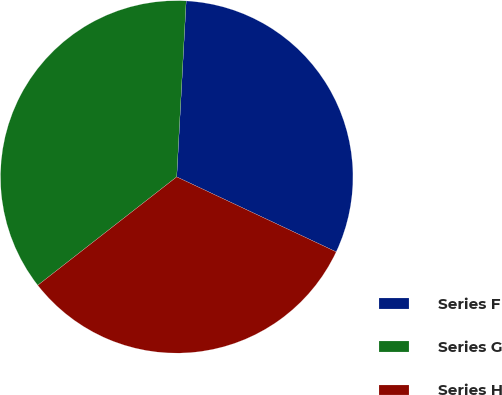Convert chart. <chart><loc_0><loc_0><loc_500><loc_500><pie_chart><fcel>Series F<fcel>Series G<fcel>Series H<nl><fcel>31.14%<fcel>36.4%<fcel>32.46%<nl></chart> 